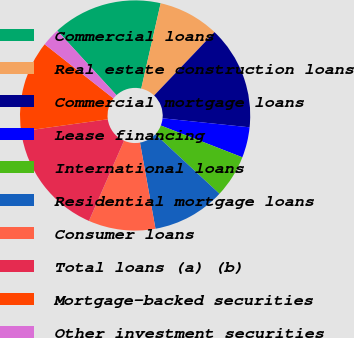Convert chart to OTSL. <chart><loc_0><loc_0><loc_500><loc_500><pie_chart><fcel>Commercial loans<fcel>Real estate construction loans<fcel>Commercial mortgage loans<fcel>Lease financing<fcel>International loans<fcel>Residential mortgage loans<fcel>Consumer loans<fcel>Total loans (a) (b)<fcel>Mortgage-backed securities<fcel>Other investment securities<nl><fcel>15.38%<fcel>8.55%<fcel>14.53%<fcel>4.28%<fcel>5.99%<fcel>10.26%<fcel>9.4%<fcel>16.23%<fcel>12.82%<fcel>2.57%<nl></chart> 